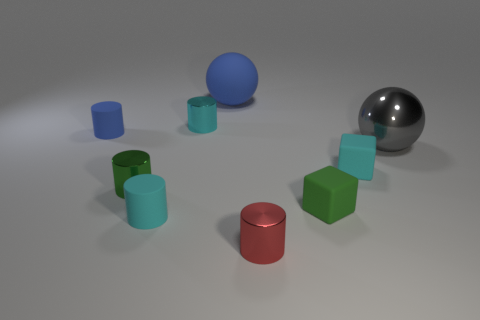How many cyan cylinders must be subtracted to get 1 cyan cylinders? 1 Subtract all green metal cylinders. How many cylinders are left? 4 Subtract all brown cylinders. Subtract all green cubes. How many cylinders are left? 5 Add 1 blue matte things. How many objects exist? 10 Subtract all cylinders. How many objects are left? 4 Add 4 large cyan matte balls. How many large cyan matte balls exist? 4 Subtract 1 gray balls. How many objects are left? 8 Subtract all small green matte objects. Subtract all blue cylinders. How many objects are left? 7 Add 7 tiny blue rubber cylinders. How many tiny blue rubber cylinders are left? 8 